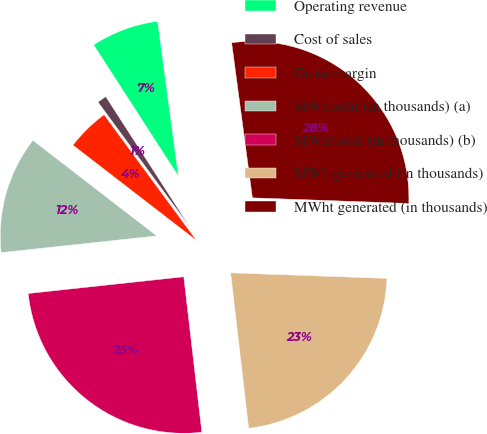<chart> <loc_0><loc_0><loc_500><loc_500><pie_chart><fcel>Operating revenue<fcel>Cost of sales<fcel>Gross margin<fcel>MWh sold (in thousands) (a)<fcel>MWht sold (in thousands) (b)<fcel>MWh generated (in thousands)<fcel>MWht generated (in thousands)<nl><fcel>7.0%<fcel>0.97%<fcel>4.45%<fcel>12.17%<fcel>25.14%<fcel>22.59%<fcel>27.69%<nl></chart> 